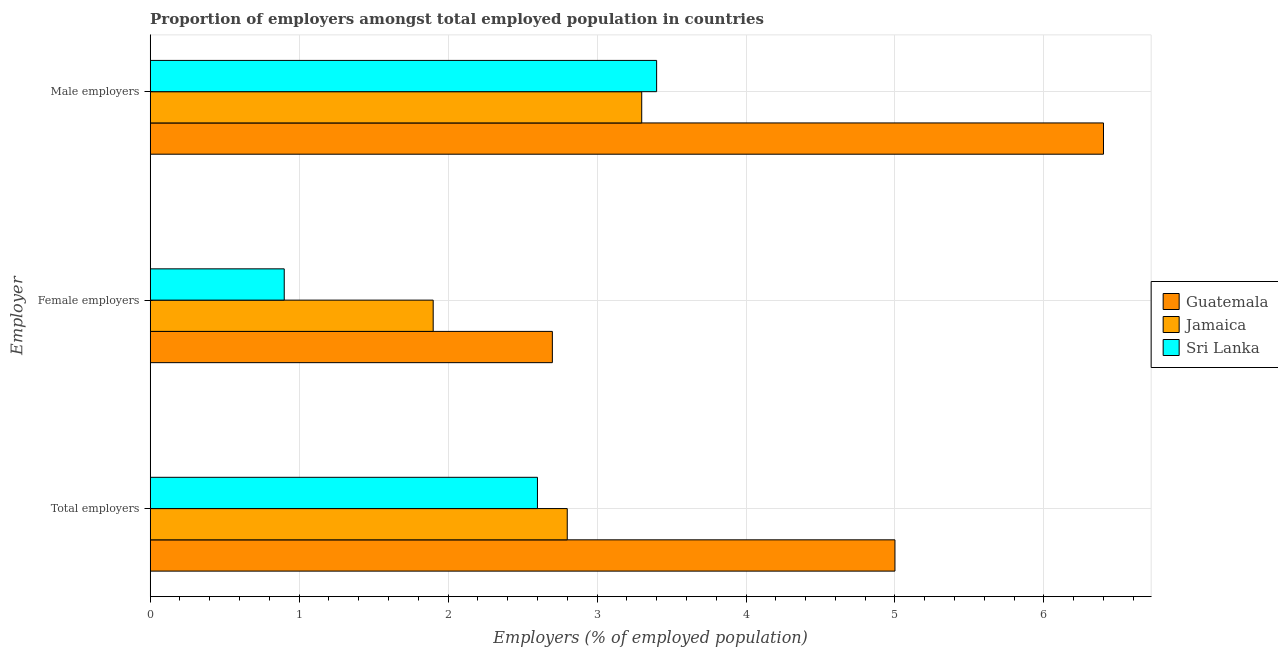How many different coloured bars are there?
Provide a succinct answer. 3. How many groups of bars are there?
Ensure brevity in your answer.  3. Are the number of bars on each tick of the Y-axis equal?
Your answer should be very brief. Yes. What is the label of the 1st group of bars from the top?
Offer a very short reply. Male employers. What is the percentage of female employers in Guatemala?
Your answer should be compact. 2.7. Across all countries, what is the maximum percentage of male employers?
Offer a terse response. 6.4. Across all countries, what is the minimum percentage of male employers?
Offer a very short reply. 3.3. In which country was the percentage of female employers maximum?
Keep it short and to the point. Guatemala. In which country was the percentage of female employers minimum?
Provide a succinct answer. Sri Lanka. What is the total percentage of female employers in the graph?
Your answer should be compact. 5.5. What is the difference between the percentage of female employers in Guatemala and that in Jamaica?
Provide a succinct answer. 0.8. What is the difference between the percentage of total employers in Sri Lanka and the percentage of female employers in Jamaica?
Your answer should be compact. 0.7. What is the average percentage of female employers per country?
Offer a terse response. 1.83. What is the difference between the percentage of female employers and percentage of male employers in Guatemala?
Make the answer very short. -3.7. In how many countries, is the percentage of total employers greater than 2.8 %?
Give a very brief answer. 1. What is the ratio of the percentage of male employers in Guatemala to that in Sri Lanka?
Ensure brevity in your answer.  1.88. Is the percentage of female employers in Guatemala less than that in Sri Lanka?
Provide a succinct answer. No. What is the difference between the highest and the second highest percentage of female employers?
Make the answer very short. 0.8. What is the difference between the highest and the lowest percentage of total employers?
Your answer should be compact. 2.4. What does the 2nd bar from the top in Male employers represents?
Give a very brief answer. Jamaica. What does the 1st bar from the bottom in Male employers represents?
Provide a succinct answer. Guatemala. What is the difference between two consecutive major ticks on the X-axis?
Your answer should be compact. 1. Are the values on the major ticks of X-axis written in scientific E-notation?
Offer a very short reply. No. Does the graph contain grids?
Ensure brevity in your answer.  Yes. Where does the legend appear in the graph?
Provide a short and direct response. Center right. How many legend labels are there?
Your answer should be very brief. 3. What is the title of the graph?
Offer a terse response. Proportion of employers amongst total employed population in countries. Does "Kuwait" appear as one of the legend labels in the graph?
Offer a terse response. No. What is the label or title of the X-axis?
Keep it short and to the point. Employers (% of employed population). What is the label or title of the Y-axis?
Provide a short and direct response. Employer. What is the Employers (% of employed population) in Jamaica in Total employers?
Provide a short and direct response. 2.8. What is the Employers (% of employed population) of Sri Lanka in Total employers?
Offer a very short reply. 2.6. What is the Employers (% of employed population) in Guatemala in Female employers?
Give a very brief answer. 2.7. What is the Employers (% of employed population) in Jamaica in Female employers?
Give a very brief answer. 1.9. What is the Employers (% of employed population) in Sri Lanka in Female employers?
Give a very brief answer. 0.9. What is the Employers (% of employed population) of Guatemala in Male employers?
Provide a succinct answer. 6.4. What is the Employers (% of employed population) of Jamaica in Male employers?
Your answer should be very brief. 3.3. What is the Employers (% of employed population) in Sri Lanka in Male employers?
Offer a terse response. 3.4. Across all Employer, what is the maximum Employers (% of employed population) of Guatemala?
Your response must be concise. 6.4. Across all Employer, what is the maximum Employers (% of employed population) of Jamaica?
Provide a short and direct response. 3.3. Across all Employer, what is the maximum Employers (% of employed population) in Sri Lanka?
Give a very brief answer. 3.4. Across all Employer, what is the minimum Employers (% of employed population) of Guatemala?
Ensure brevity in your answer.  2.7. Across all Employer, what is the minimum Employers (% of employed population) in Jamaica?
Make the answer very short. 1.9. Across all Employer, what is the minimum Employers (% of employed population) in Sri Lanka?
Keep it short and to the point. 0.9. What is the total Employers (% of employed population) of Sri Lanka in the graph?
Provide a short and direct response. 6.9. What is the difference between the Employers (% of employed population) in Guatemala in Total employers and that in Female employers?
Offer a very short reply. 2.3. What is the difference between the Employers (% of employed population) of Jamaica in Total employers and that in Female employers?
Your answer should be very brief. 0.9. What is the difference between the Employers (% of employed population) in Sri Lanka in Total employers and that in Female employers?
Provide a short and direct response. 1.7. What is the difference between the Employers (% of employed population) of Guatemala in Total employers and that in Male employers?
Keep it short and to the point. -1.4. What is the difference between the Employers (% of employed population) of Jamaica in Total employers and that in Male employers?
Your answer should be very brief. -0.5. What is the difference between the Employers (% of employed population) in Sri Lanka in Total employers and that in Male employers?
Ensure brevity in your answer.  -0.8. What is the difference between the Employers (% of employed population) of Guatemala in Total employers and the Employers (% of employed population) of Jamaica in Female employers?
Offer a very short reply. 3.1. What is the difference between the Employers (% of employed population) in Guatemala in Total employers and the Employers (% of employed population) in Sri Lanka in Female employers?
Your answer should be compact. 4.1. What is the difference between the Employers (% of employed population) in Jamaica in Total employers and the Employers (% of employed population) in Sri Lanka in Female employers?
Make the answer very short. 1.9. What is the difference between the Employers (% of employed population) of Jamaica in Total employers and the Employers (% of employed population) of Sri Lanka in Male employers?
Offer a terse response. -0.6. What is the difference between the Employers (% of employed population) in Guatemala in Female employers and the Employers (% of employed population) in Sri Lanka in Male employers?
Offer a terse response. -0.7. What is the difference between the Employers (% of employed population) in Jamaica in Female employers and the Employers (% of employed population) in Sri Lanka in Male employers?
Your response must be concise. -1.5. What is the average Employers (% of employed population) in Jamaica per Employer?
Your answer should be compact. 2.67. What is the average Employers (% of employed population) in Sri Lanka per Employer?
Ensure brevity in your answer.  2.3. What is the difference between the Employers (% of employed population) of Jamaica and Employers (% of employed population) of Sri Lanka in Total employers?
Provide a succinct answer. 0.2. What is the ratio of the Employers (% of employed population) in Guatemala in Total employers to that in Female employers?
Provide a short and direct response. 1.85. What is the ratio of the Employers (% of employed population) of Jamaica in Total employers to that in Female employers?
Ensure brevity in your answer.  1.47. What is the ratio of the Employers (% of employed population) in Sri Lanka in Total employers to that in Female employers?
Your answer should be compact. 2.89. What is the ratio of the Employers (% of employed population) in Guatemala in Total employers to that in Male employers?
Ensure brevity in your answer.  0.78. What is the ratio of the Employers (% of employed population) of Jamaica in Total employers to that in Male employers?
Keep it short and to the point. 0.85. What is the ratio of the Employers (% of employed population) in Sri Lanka in Total employers to that in Male employers?
Make the answer very short. 0.76. What is the ratio of the Employers (% of employed population) of Guatemala in Female employers to that in Male employers?
Offer a very short reply. 0.42. What is the ratio of the Employers (% of employed population) of Jamaica in Female employers to that in Male employers?
Give a very brief answer. 0.58. What is the ratio of the Employers (% of employed population) in Sri Lanka in Female employers to that in Male employers?
Offer a terse response. 0.26. What is the difference between the highest and the second highest Employers (% of employed population) of Guatemala?
Offer a very short reply. 1.4. What is the difference between the highest and the second highest Employers (% of employed population) of Jamaica?
Ensure brevity in your answer.  0.5. What is the difference between the highest and the second highest Employers (% of employed population) in Sri Lanka?
Keep it short and to the point. 0.8. 